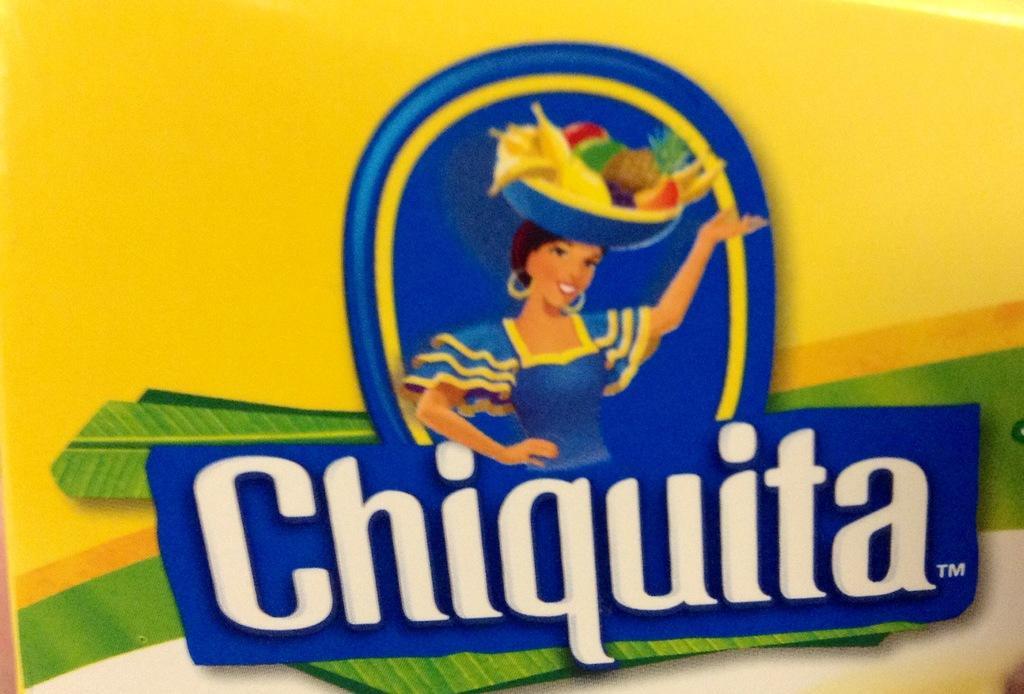Could you give a brief overview of what you see in this image? In this image we can see an animated picture of a woman holding a basket with some fruits in it. We can also see some text under the picture. 